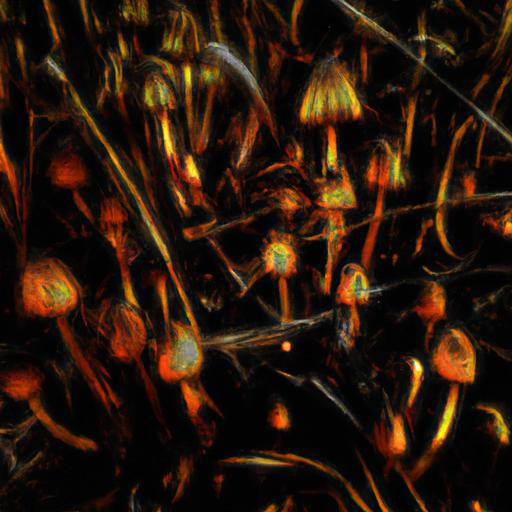What artistic techniques could have been used to create this image? The image seems to utilize digital manipulation techniques, combining elements of photography with digital painting or filtering. The glowing effect could have been achieved through a combination of contrast adjustments and selective color enhancements to give it an otherworldly appearance. 